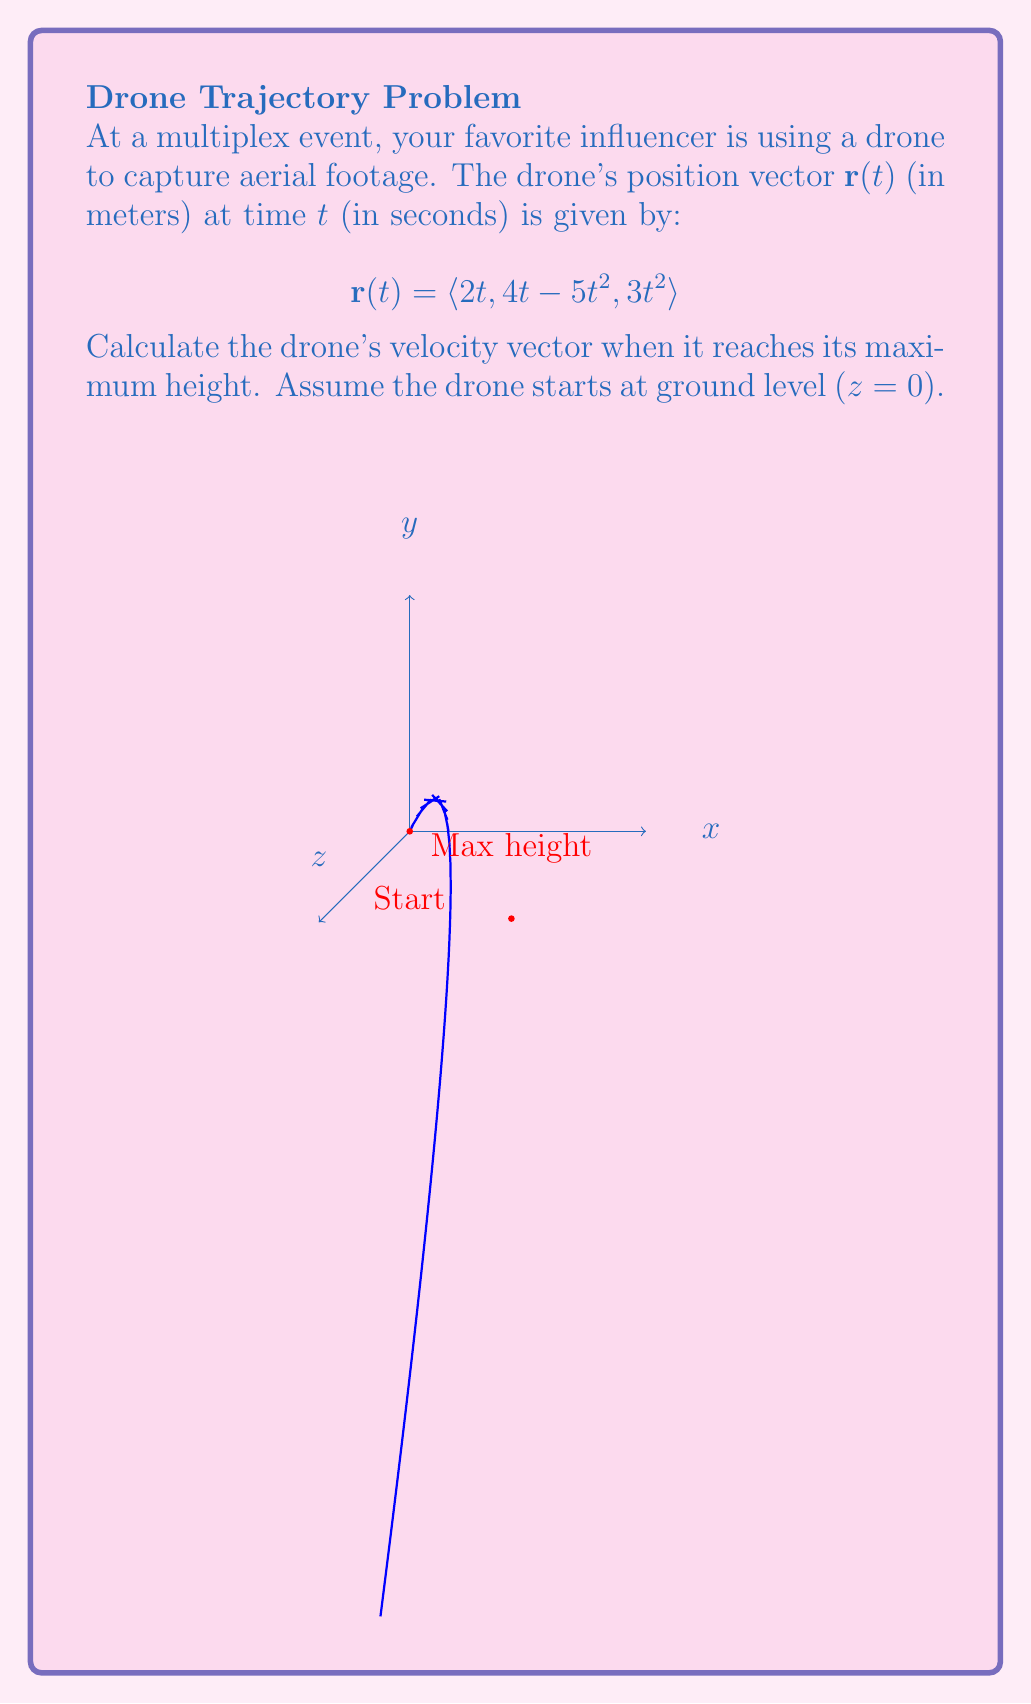What is the answer to this math problem? Let's approach this step-by-step:

1) First, we need to find when the drone reaches its maximum height. The z-component of the position vector represents the height:

   $z(t) = 3t^2$

2) To find the maximum height, we need to find when the vertical velocity is zero:

   $\frac{dz}{dt} = 6t = 0$
   $t = 0$

   However, $t = 0$ is the starting point. The other critical point is when the drone returns to the ground. Let's solve:

   $3t^2 = 0$
   $t = 0$ or $t = 0$

3) This means the drone never returns to the ground. The maximum height occurs at the latest time in the given domain. Let's find when $y = 0$:

   $4t - 5t^2 = 0$
   $t(4 - 5t) = 0$
   $t = 0$ or $t = \frac{4}{5}$

4) Therefore, the maximum height occurs at $t = \frac{4}{5}$.

5) Now, let's calculate the velocity vector. The velocity is the derivative of the position vector:

   $$\mathbf{v}(t) = \frac{d}{dt}\mathbf{r}(t) = \langle 2, 4 - 10t, 6t \rangle$$

6) At $t = \frac{4}{5}$, the velocity vector is:

   $$\mathbf{v}(\frac{4}{5}) = \langle 2, 4 - 10(\frac{4}{5}), 6(\frac{4}{5}) \rangle = \langle 2, -4, \frac{24}{5} \rangle$$
Answer: $\langle 2, -4, \frac{24}{5} \rangle$ m/s 